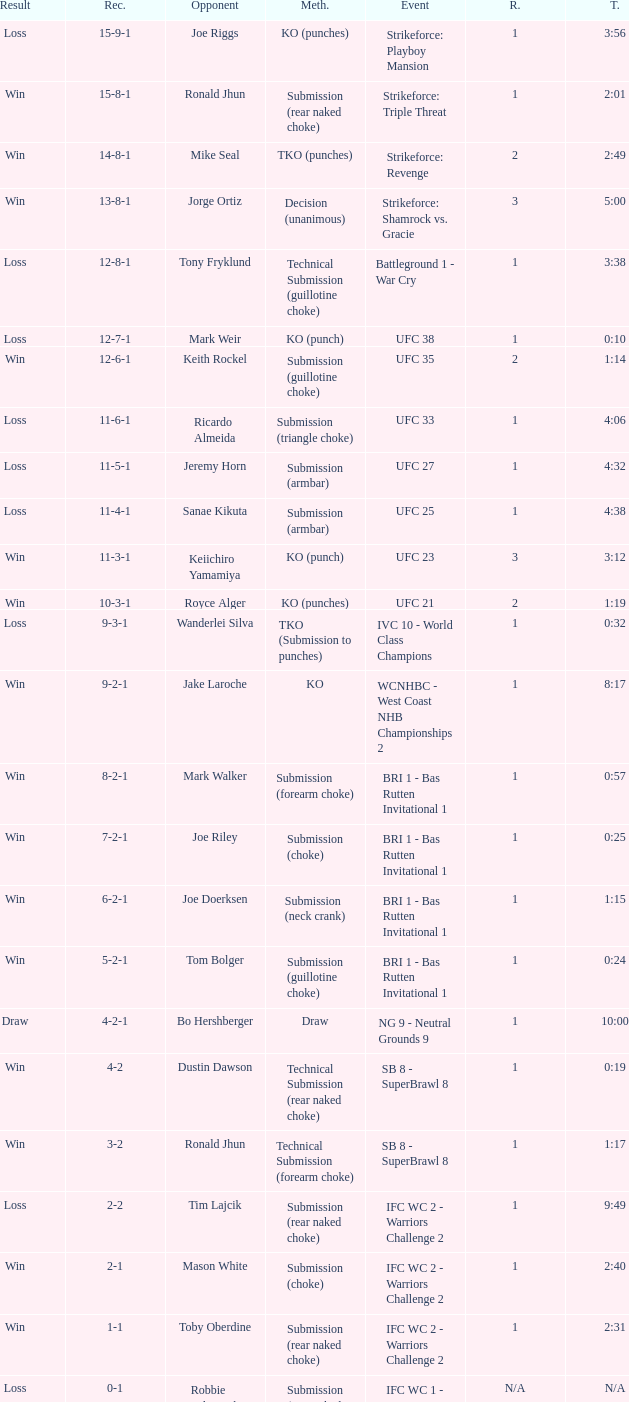When the fight lasted only 10 seconds, who was the adversary? Mark Weir. 